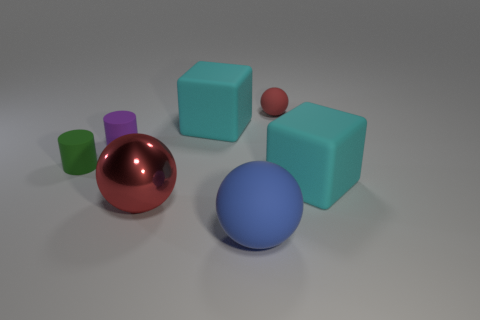Is there anything else that is made of the same material as the large red ball?
Your answer should be compact. No. There is a large rubber object that is in front of the red object left of the small matte sphere; how many large blue rubber things are in front of it?
Your answer should be compact. 0. What number of cylinders are either tiny matte objects or tiny red rubber objects?
Provide a short and direct response. 2. What is the color of the matte cube that is to the left of the cyan matte cube that is in front of the big cube left of the tiny sphere?
Offer a terse response. Cyan. What number of other objects are the same size as the blue object?
Provide a succinct answer. 3. What color is the other tiny object that is the same shape as the metal object?
Your response must be concise. Red. There is a cylinder that is made of the same material as the green object; what is its color?
Make the answer very short. Purple. Is the number of purple matte cylinders in front of the purple rubber thing the same as the number of large cyan rubber cylinders?
Ensure brevity in your answer.  Yes. Is the size of the cyan object to the left of the blue rubber sphere the same as the blue ball?
Provide a short and direct response. Yes. What color is the ball that is the same size as the green rubber thing?
Your answer should be very brief. Red. 